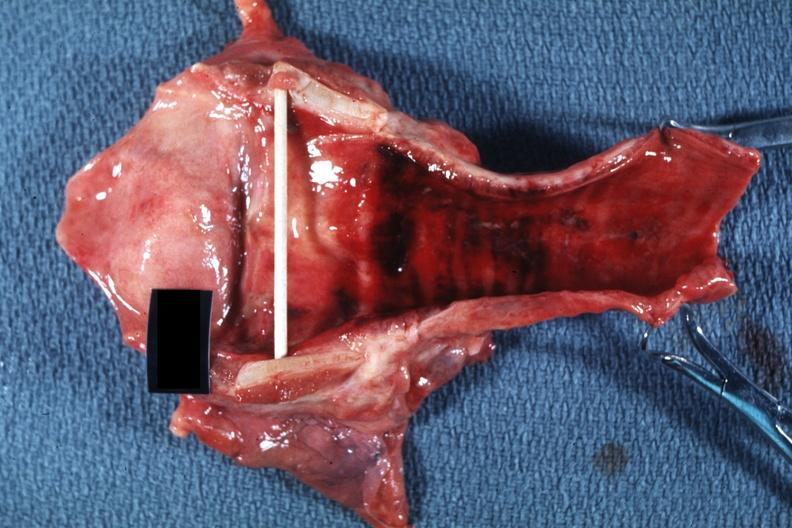what does this image show?
Answer the question using a single word or phrase. Good example probably due to intubation 